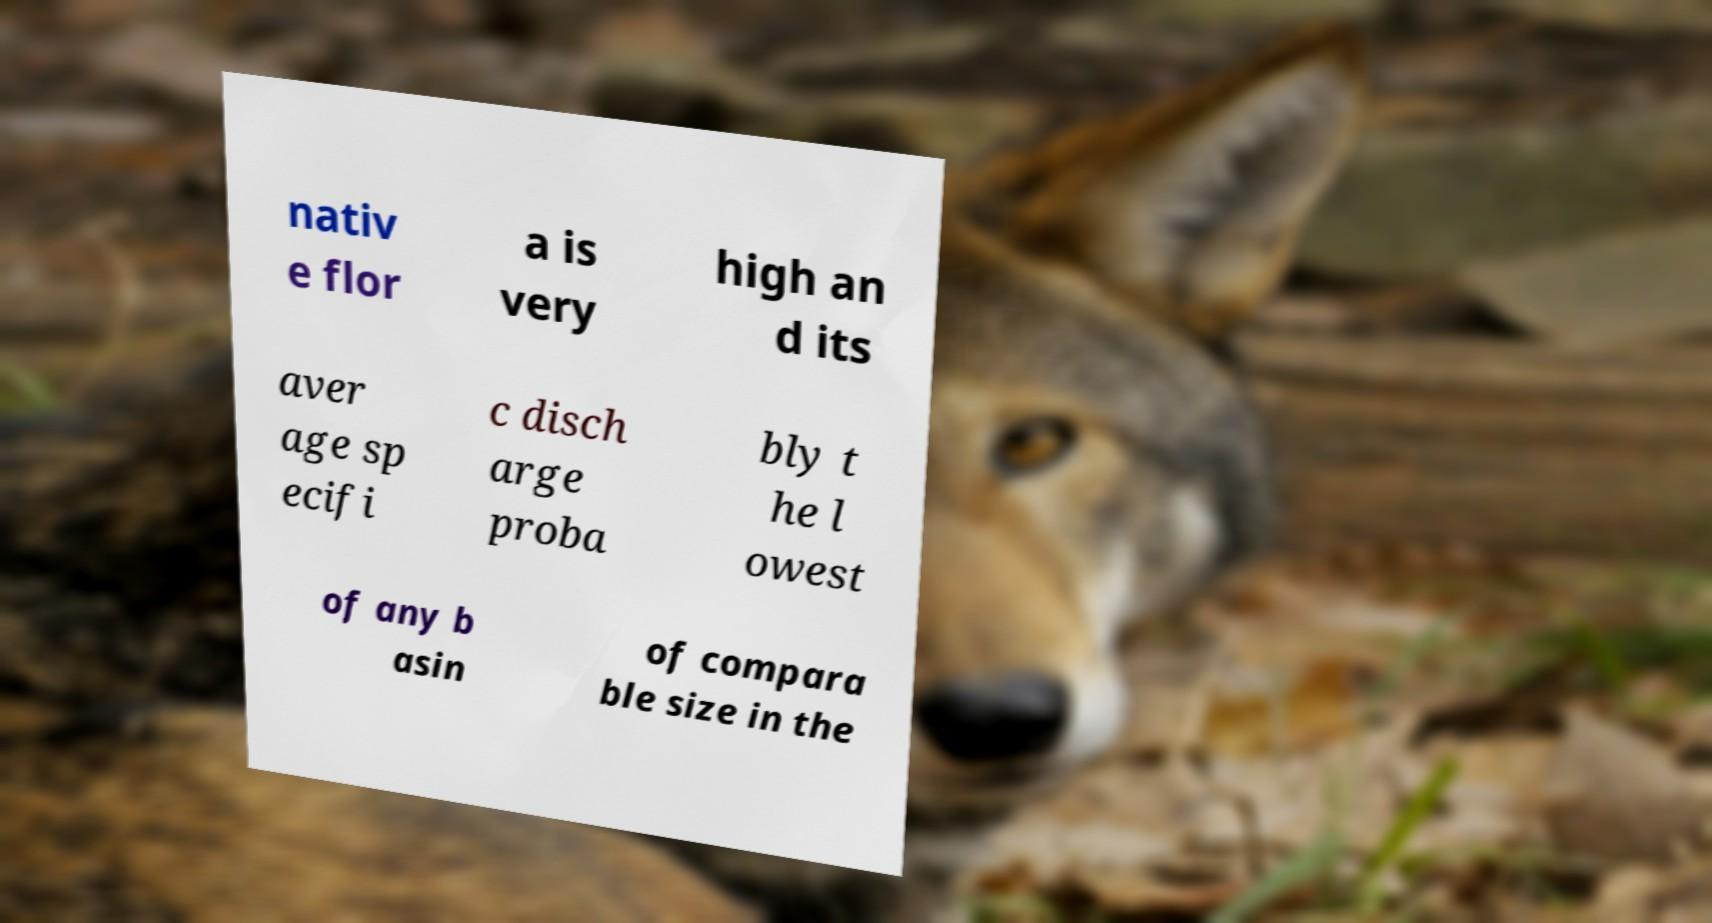Please read and relay the text visible in this image. What does it say? nativ e flor a is very high an d its aver age sp ecifi c disch arge proba bly t he l owest of any b asin of compara ble size in the 